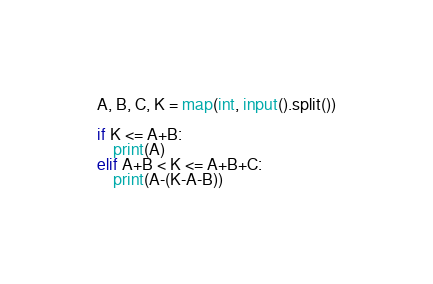Convert code to text. <code><loc_0><loc_0><loc_500><loc_500><_Python_>A, B, C, K = map(int, input().split())

if K <= A+B:
    print(A)
elif A+B < K <= A+B+C:
    print(A-(K-A-B))
</code> 